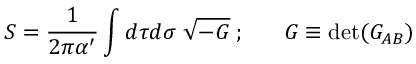<formula> <loc_0><loc_0><loc_500><loc_500>S = \frac { 1 } { 2 \pi \alpha ^ { \prime } } \int d \tau d \sigma \, \sqrt { - G } \, ; \, G \equiv d e t ( G _ { A B } )</formula> 